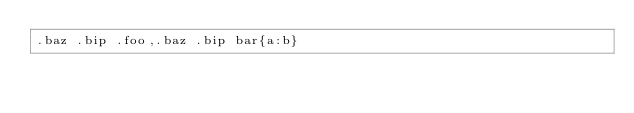<code> <loc_0><loc_0><loc_500><loc_500><_CSS_>.baz .bip .foo,.baz .bip bar{a:b}
</code> 